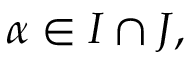<formula> <loc_0><loc_0><loc_500><loc_500>\alpha \in I \cap J ,</formula> 